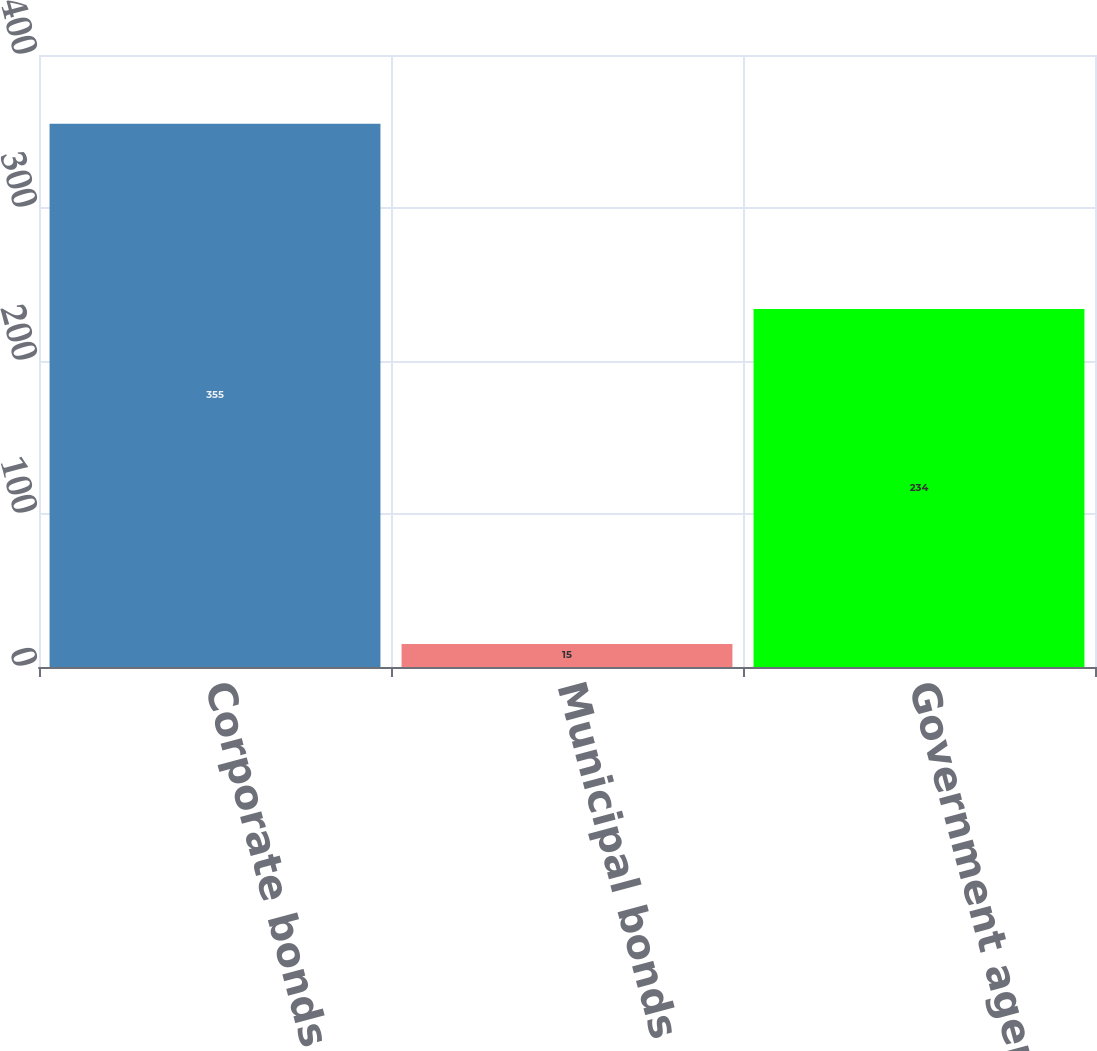Convert chart to OTSL. <chart><loc_0><loc_0><loc_500><loc_500><bar_chart><fcel>Corporate bonds<fcel>Municipal bonds<fcel>Government agency bonds<nl><fcel>355<fcel>15<fcel>234<nl></chart> 